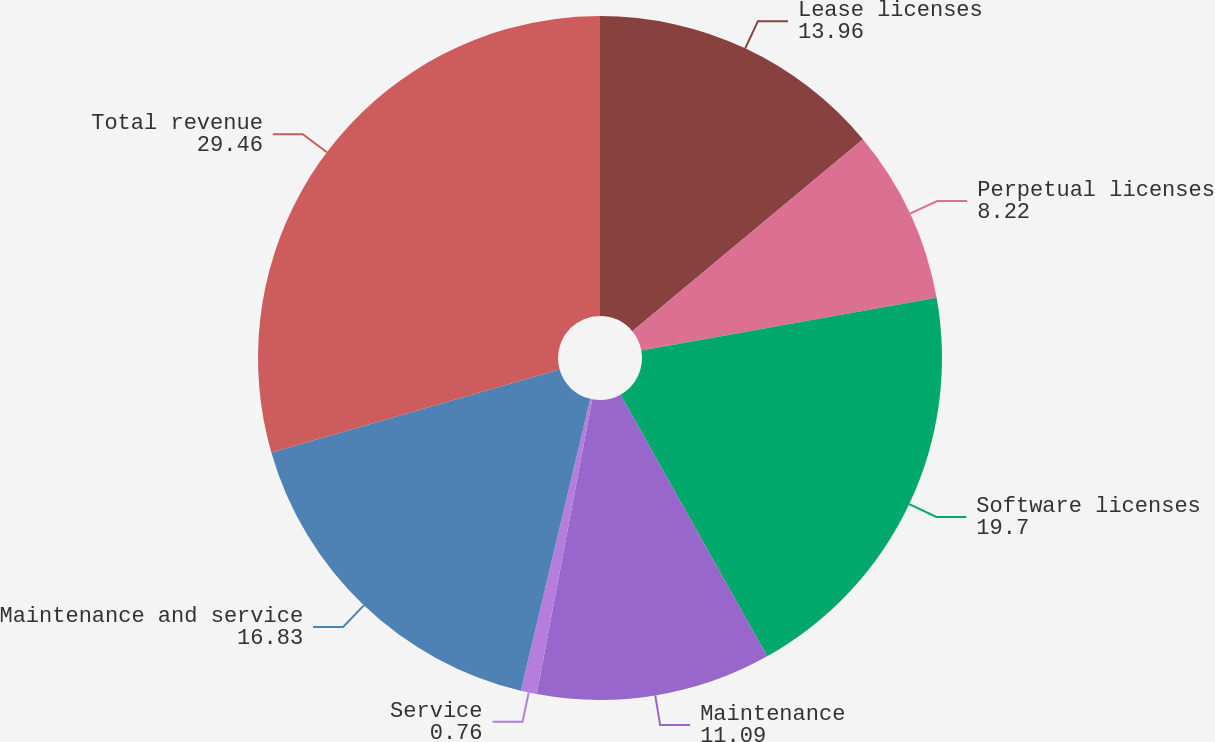<chart> <loc_0><loc_0><loc_500><loc_500><pie_chart><fcel>Lease licenses<fcel>Perpetual licenses<fcel>Software licenses<fcel>Maintenance<fcel>Service<fcel>Maintenance and service<fcel>Total revenue<nl><fcel>13.96%<fcel>8.22%<fcel>19.7%<fcel>11.09%<fcel>0.76%<fcel>16.83%<fcel>29.46%<nl></chart> 